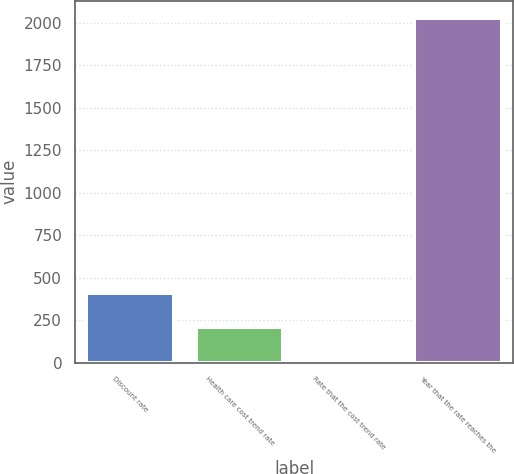Convert chart to OTSL. <chart><loc_0><loc_0><loc_500><loc_500><bar_chart><fcel>Discount rate<fcel>Health care cost trend rate<fcel>Rate that the cost trend rate<fcel>Year that the rate reaches the<nl><fcel>409.96<fcel>207.95<fcel>5.94<fcel>2026<nl></chart> 